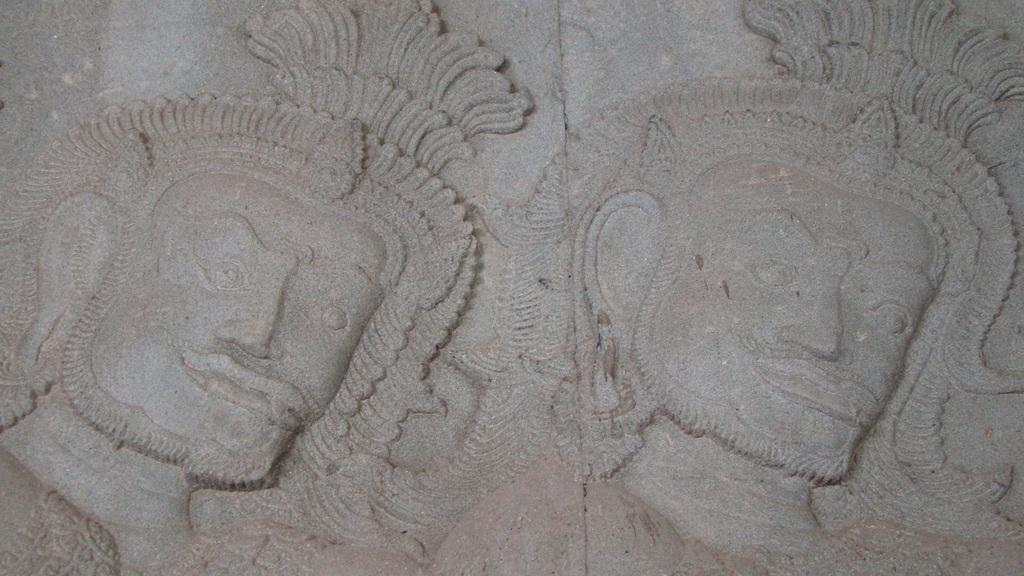What is depicted on the rock in the image? There are carving arts on a rock in the image. Can you describe the carving arts in more detail? Unfortunately, the details of the carving arts cannot be discerned from the provided facts. What type of surface is the carving arts done on? The carving arts are done on a rock. What grade does the bear receive for its performance in the image? There is no bear present in the image, so it cannot receive a grade for any performance. 